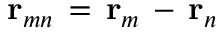<formula> <loc_0><loc_0><loc_500><loc_500>{ r } _ { m n } \, = \, { r } _ { m } \, - \, { r } _ { n }</formula> 